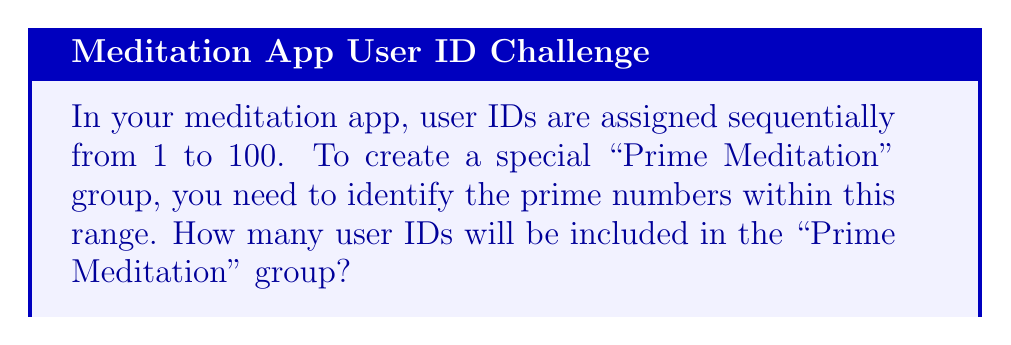Show me your answer to this math problem. To solve this problem, we need to follow these steps:

1. Recall the definition of a prime number: A prime number is a natural number greater than 1 that is only divisible by 1 and itself.

2. Identify the prime numbers within the range of 1 to 100:
   $2, 3, 5, 7, 11, 13, 17, 19, 23, 29, 31, 37, 41, 43, 47, 53, 59, 61, 67, 71, 73, 79, 83, 89, 97$

3. To find these prime numbers, we can use the Sieve of Eratosthenes method:
   a) Create a list of all numbers from 2 to 100.
   b) Start with the first number (2) and mark all its multiples as non-prime.
   c) Move to the next unmarked number and repeat step b.
   d) Continue until we reach $\sqrt{100} \approx 10$.

4. After applying the Sieve of Eratosthenes, the unmarked numbers are the primes.

5. Count the number of prime numbers in the list:
   $$\text{Number of primes} = 25$$

Therefore, there will be 25 user IDs included in the "Prime Meditation" group.
Answer: 25 